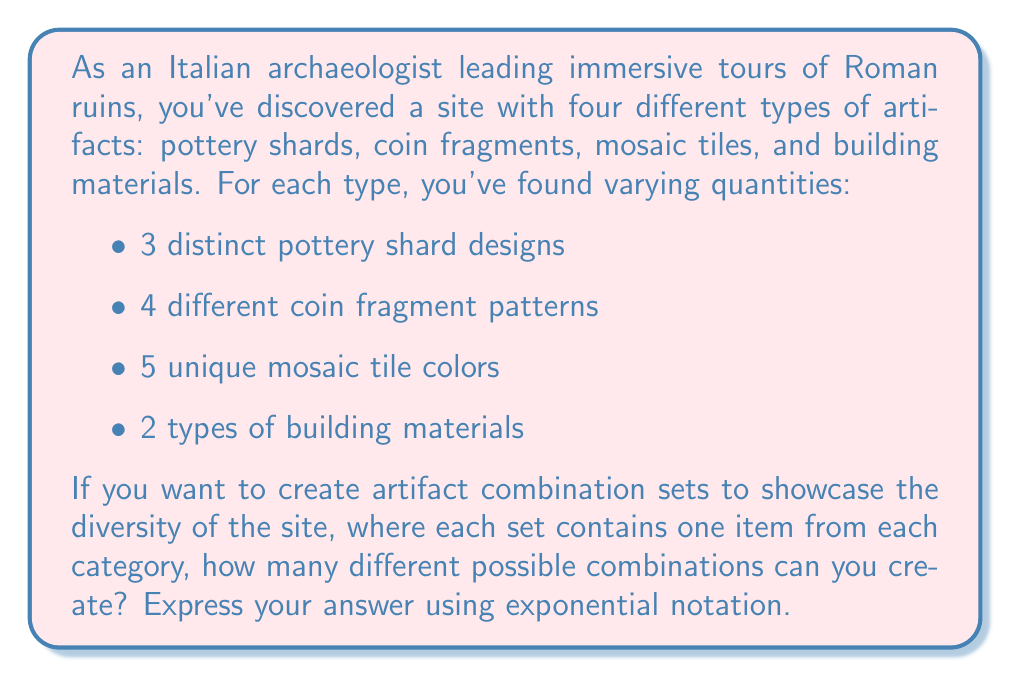Give your solution to this math problem. To solve this problem, we need to use the multiplication principle of counting. For each category of artifact, we have a certain number of choices:

1. Pottery shards: 3 choices
2. Coin fragments: 4 choices
3. Mosaic tiles: 5 choices
4. Building materials: 2 choices

To find the total number of possible combinations, we multiply these numbers together:

$$ \text{Total combinations} = 3 \times 4 \times 5 \times 2 $$

Now, we can express this as an exponential expression. Notice that we are multiplying four different numbers, each representing the number of choices for a category. We can rewrite this as:

$$ \text{Total combinations} = 3^1 \times 4^1 \times 5^1 \times 2^1 $$

In exponential notation, when we multiply terms with the same base, we add the exponents. However, in this case, each base is different, so we keep the expression as is.

Therefore, the number of possible artifact combinations, expressed using exponential notation, is:

$$ 3^1 \times 4^1 \times 5^1 \times 2^1 $$

If we calculate this, we get:

$$ 3 \times 4 \times 5 \times 2 = 120 $$

So, there are 120 possible combinations of artifacts.
Answer: $3^1 \times 4^1 \times 5^1 \times 2^1$ or 120 combinations 